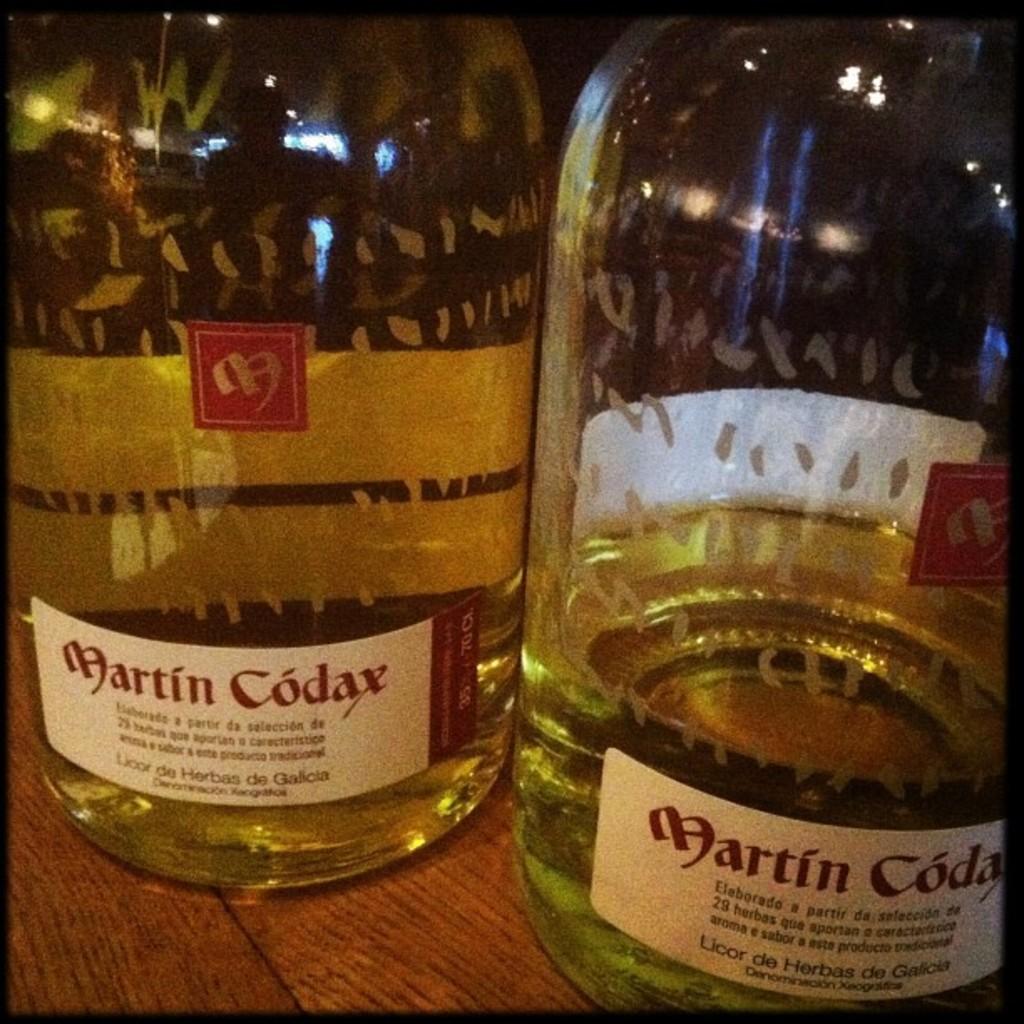What kind of liquor is martin codax?
Keep it short and to the point. Licor de herbas de galicia. 